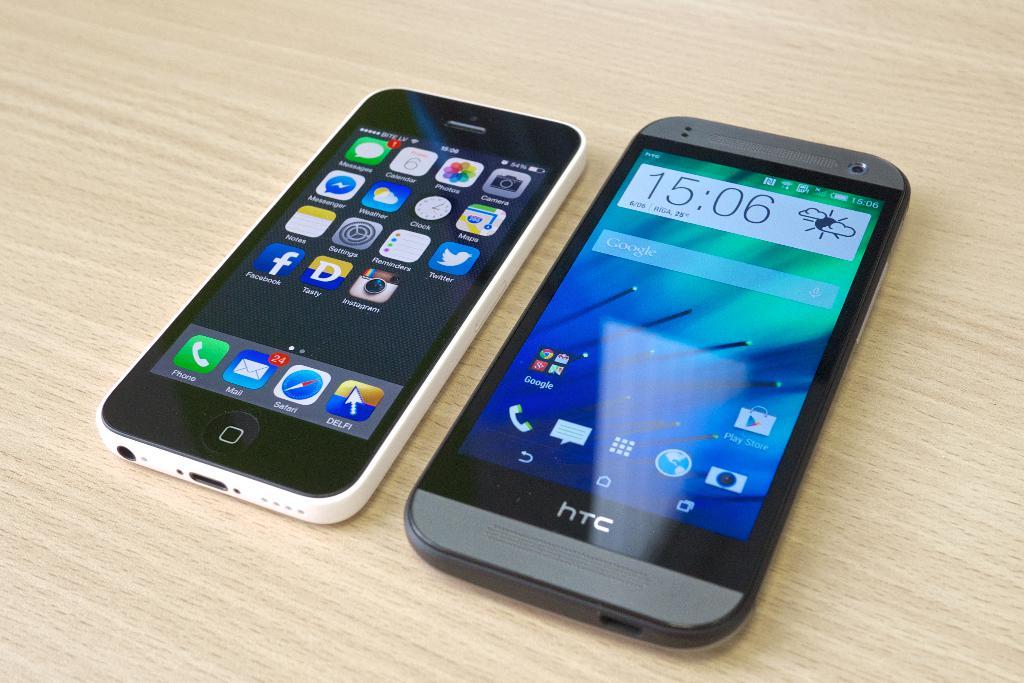What brand is the larger phone?
Give a very brief answer. Htc. What time is it?
Ensure brevity in your answer.  15:06. 